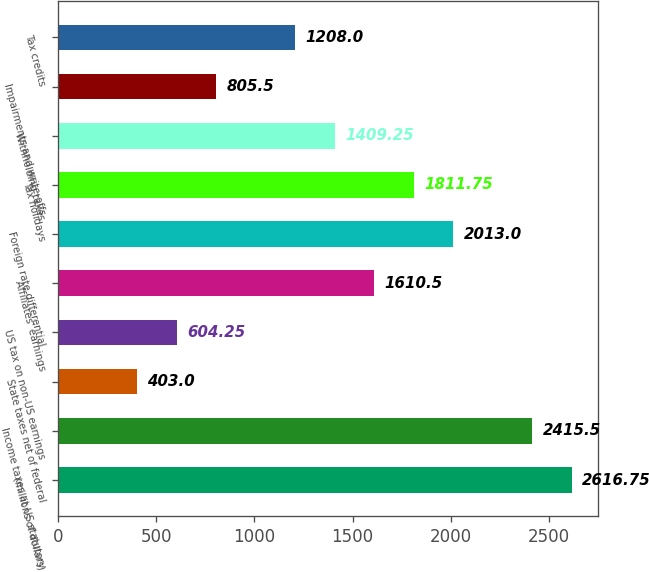Convert chart. <chart><loc_0><loc_0><loc_500><loc_500><bar_chart><fcel>(millions of dollars)<fcel>Income taxes at US statutory<fcel>State taxes net of federal<fcel>US tax on non-US earnings<fcel>Affiliates' earnings<fcel>Foreign rate differential<fcel>Tax holidays<fcel>Withholding taxes<fcel>Impairments and write-offs<fcel>Tax credits<nl><fcel>2616.75<fcel>2415.5<fcel>403<fcel>604.25<fcel>1610.5<fcel>2013<fcel>1811.75<fcel>1409.25<fcel>805.5<fcel>1208<nl></chart> 